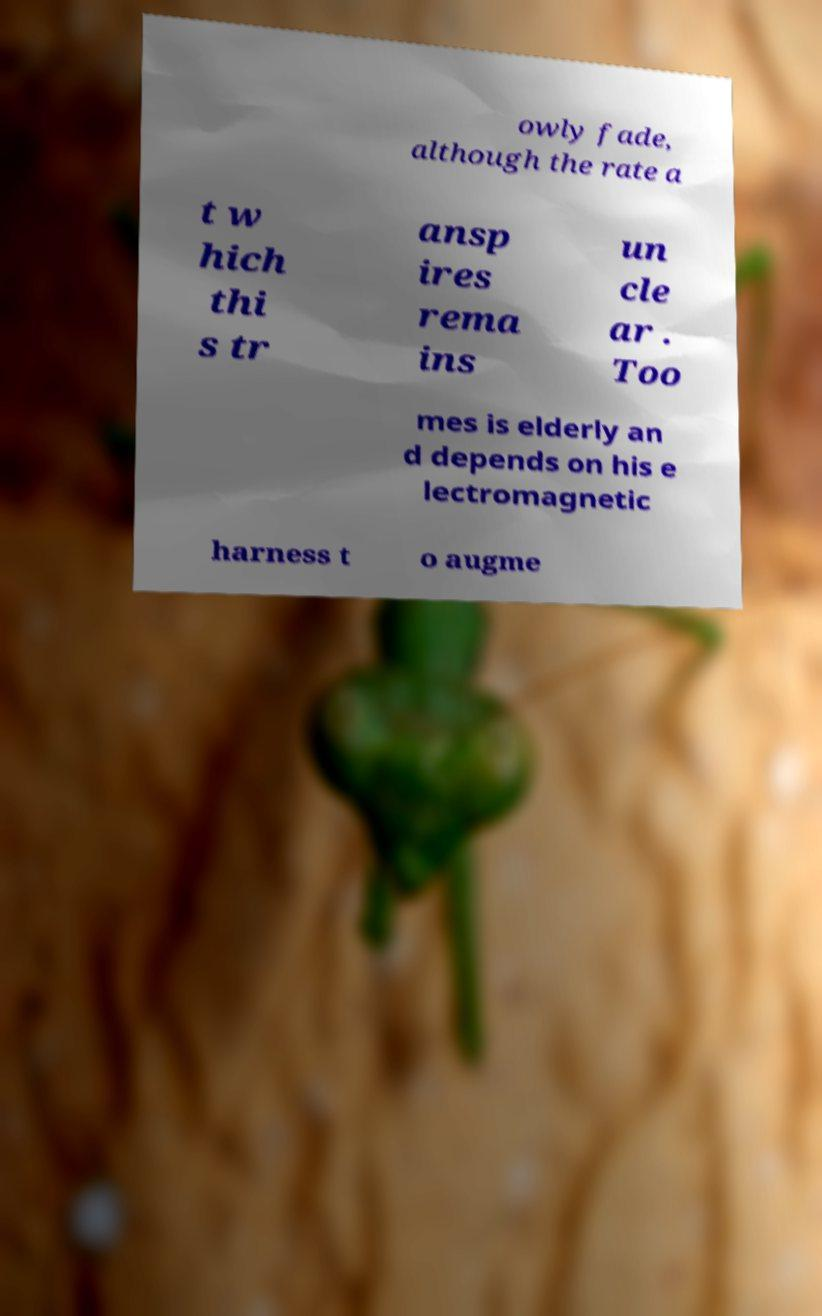I need the written content from this picture converted into text. Can you do that? owly fade, although the rate a t w hich thi s tr ansp ires rema ins un cle ar . Too mes is elderly an d depends on his e lectromagnetic harness t o augme 